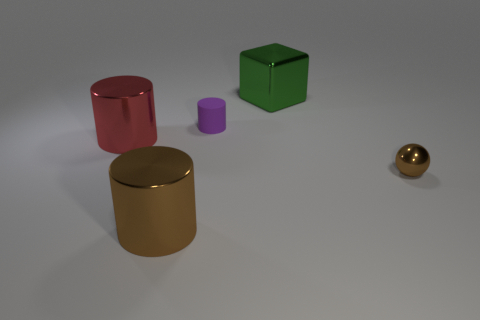Subtract all large cylinders. How many cylinders are left? 1 Subtract all red cylinders. How many cylinders are left? 2 Add 2 green metallic things. How many objects exist? 7 Subtract all blocks. How many objects are left? 4 Subtract 1 cylinders. How many cylinders are left? 2 Subtract all yellow cylinders. Subtract all gray balls. How many cylinders are left? 3 Subtract all tiny gray metal blocks. Subtract all tiny purple cylinders. How many objects are left? 4 Add 3 small brown metal spheres. How many small brown metal spheres are left? 4 Add 5 large metallic objects. How many large metallic objects exist? 8 Subtract 0 cyan balls. How many objects are left? 5 